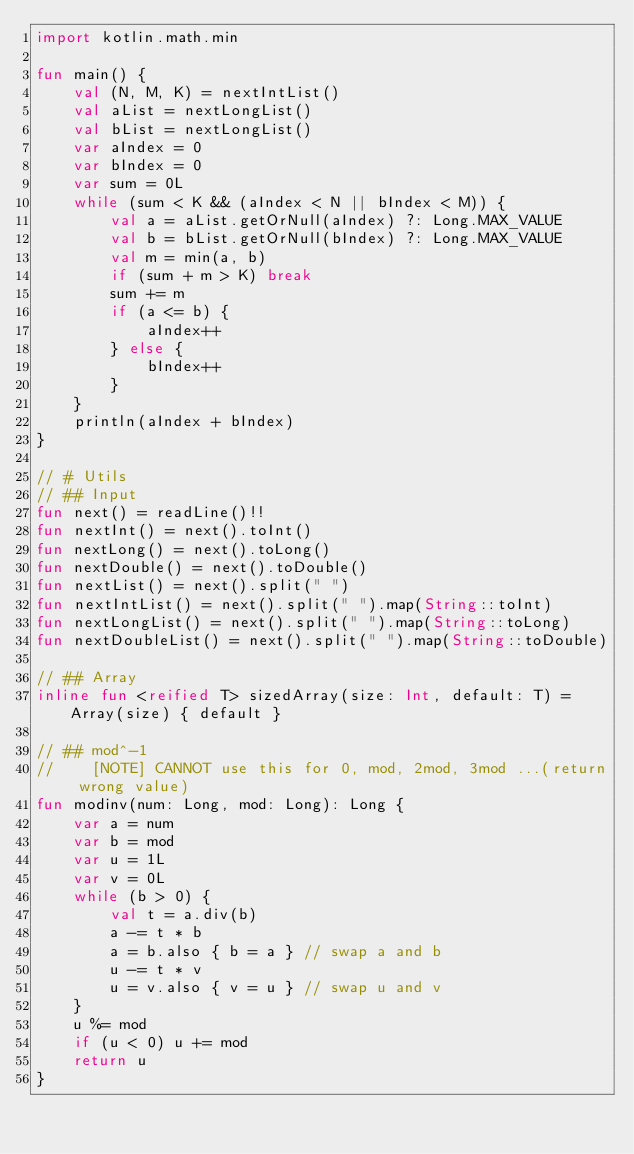<code> <loc_0><loc_0><loc_500><loc_500><_Kotlin_>import kotlin.math.min

fun main() {
    val (N, M, K) = nextIntList()
    val aList = nextLongList()
    val bList = nextLongList()
    var aIndex = 0
    var bIndex = 0
    var sum = 0L
    while (sum < K && (aIndex < N || bIndex < M)) {
        val a = aList.getOrNull(aIndex) ?: Long.MAX_VALUE
        val b = bList.getOrNull(bIndex) ?: Long.MAX_VALUE
        val m = min(a, b)
        if (sum + m > K) break
        sum += m
        if (a <= b) {
            aIndex++
        } else {
            bIndex++
        }
    }
    println(aIndex + bIndex)
}

// # Utils
// ## Input
fun next() = readLine()!!
fun nextInt() = next().toInt()
fun nextLong() = next().toLong()
fun nextDouble() = next().toDouble()
fun nextList() = next().split(" ")
fun nextIntList() = next().split(" ").map(String::toInt)
fun nextLongList() = next().split(" ").map(String::toLong)
fun nextDoubleList() = next().split(" ").map(String::toDouble)

// ## Array
inline fun <reified T> sizedArray(size: Int, default: T) = Array(size) { default }

// ## mod^-1
//    [NOTE] CANNOT use this for 0, mod, 2mod, 3mod ...(return wrong value)
fun modinv(num: Long, mod: Long): Long {
    var a = num
    var b = mod
    var u = 1L
    var v = 0L
    while (b > 0) {
        val t = a.div(b)
        a -= t * b
        a = b.also { b = a } // swap a and b
        u -= t * v
        u = v.also { v = u } // swap u and v
    }
    u %= mod
    if (u < 0) u += mod
    return u
}</code> 